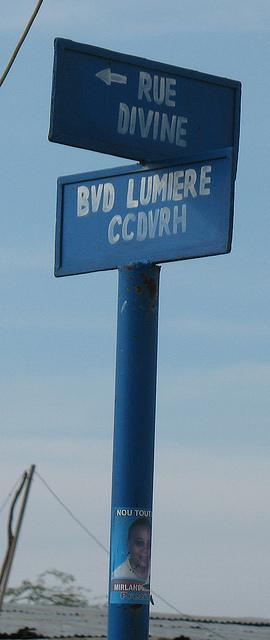What is the arrow pointing to?
Quick response, please. True divine. What language are the signs?
Keep it brief. French. What country is this?
Quick response, please. France. What does the sticker say?
Keep it brief. True divine. What is on  the pole?
Give a very brief answer. Signs. 